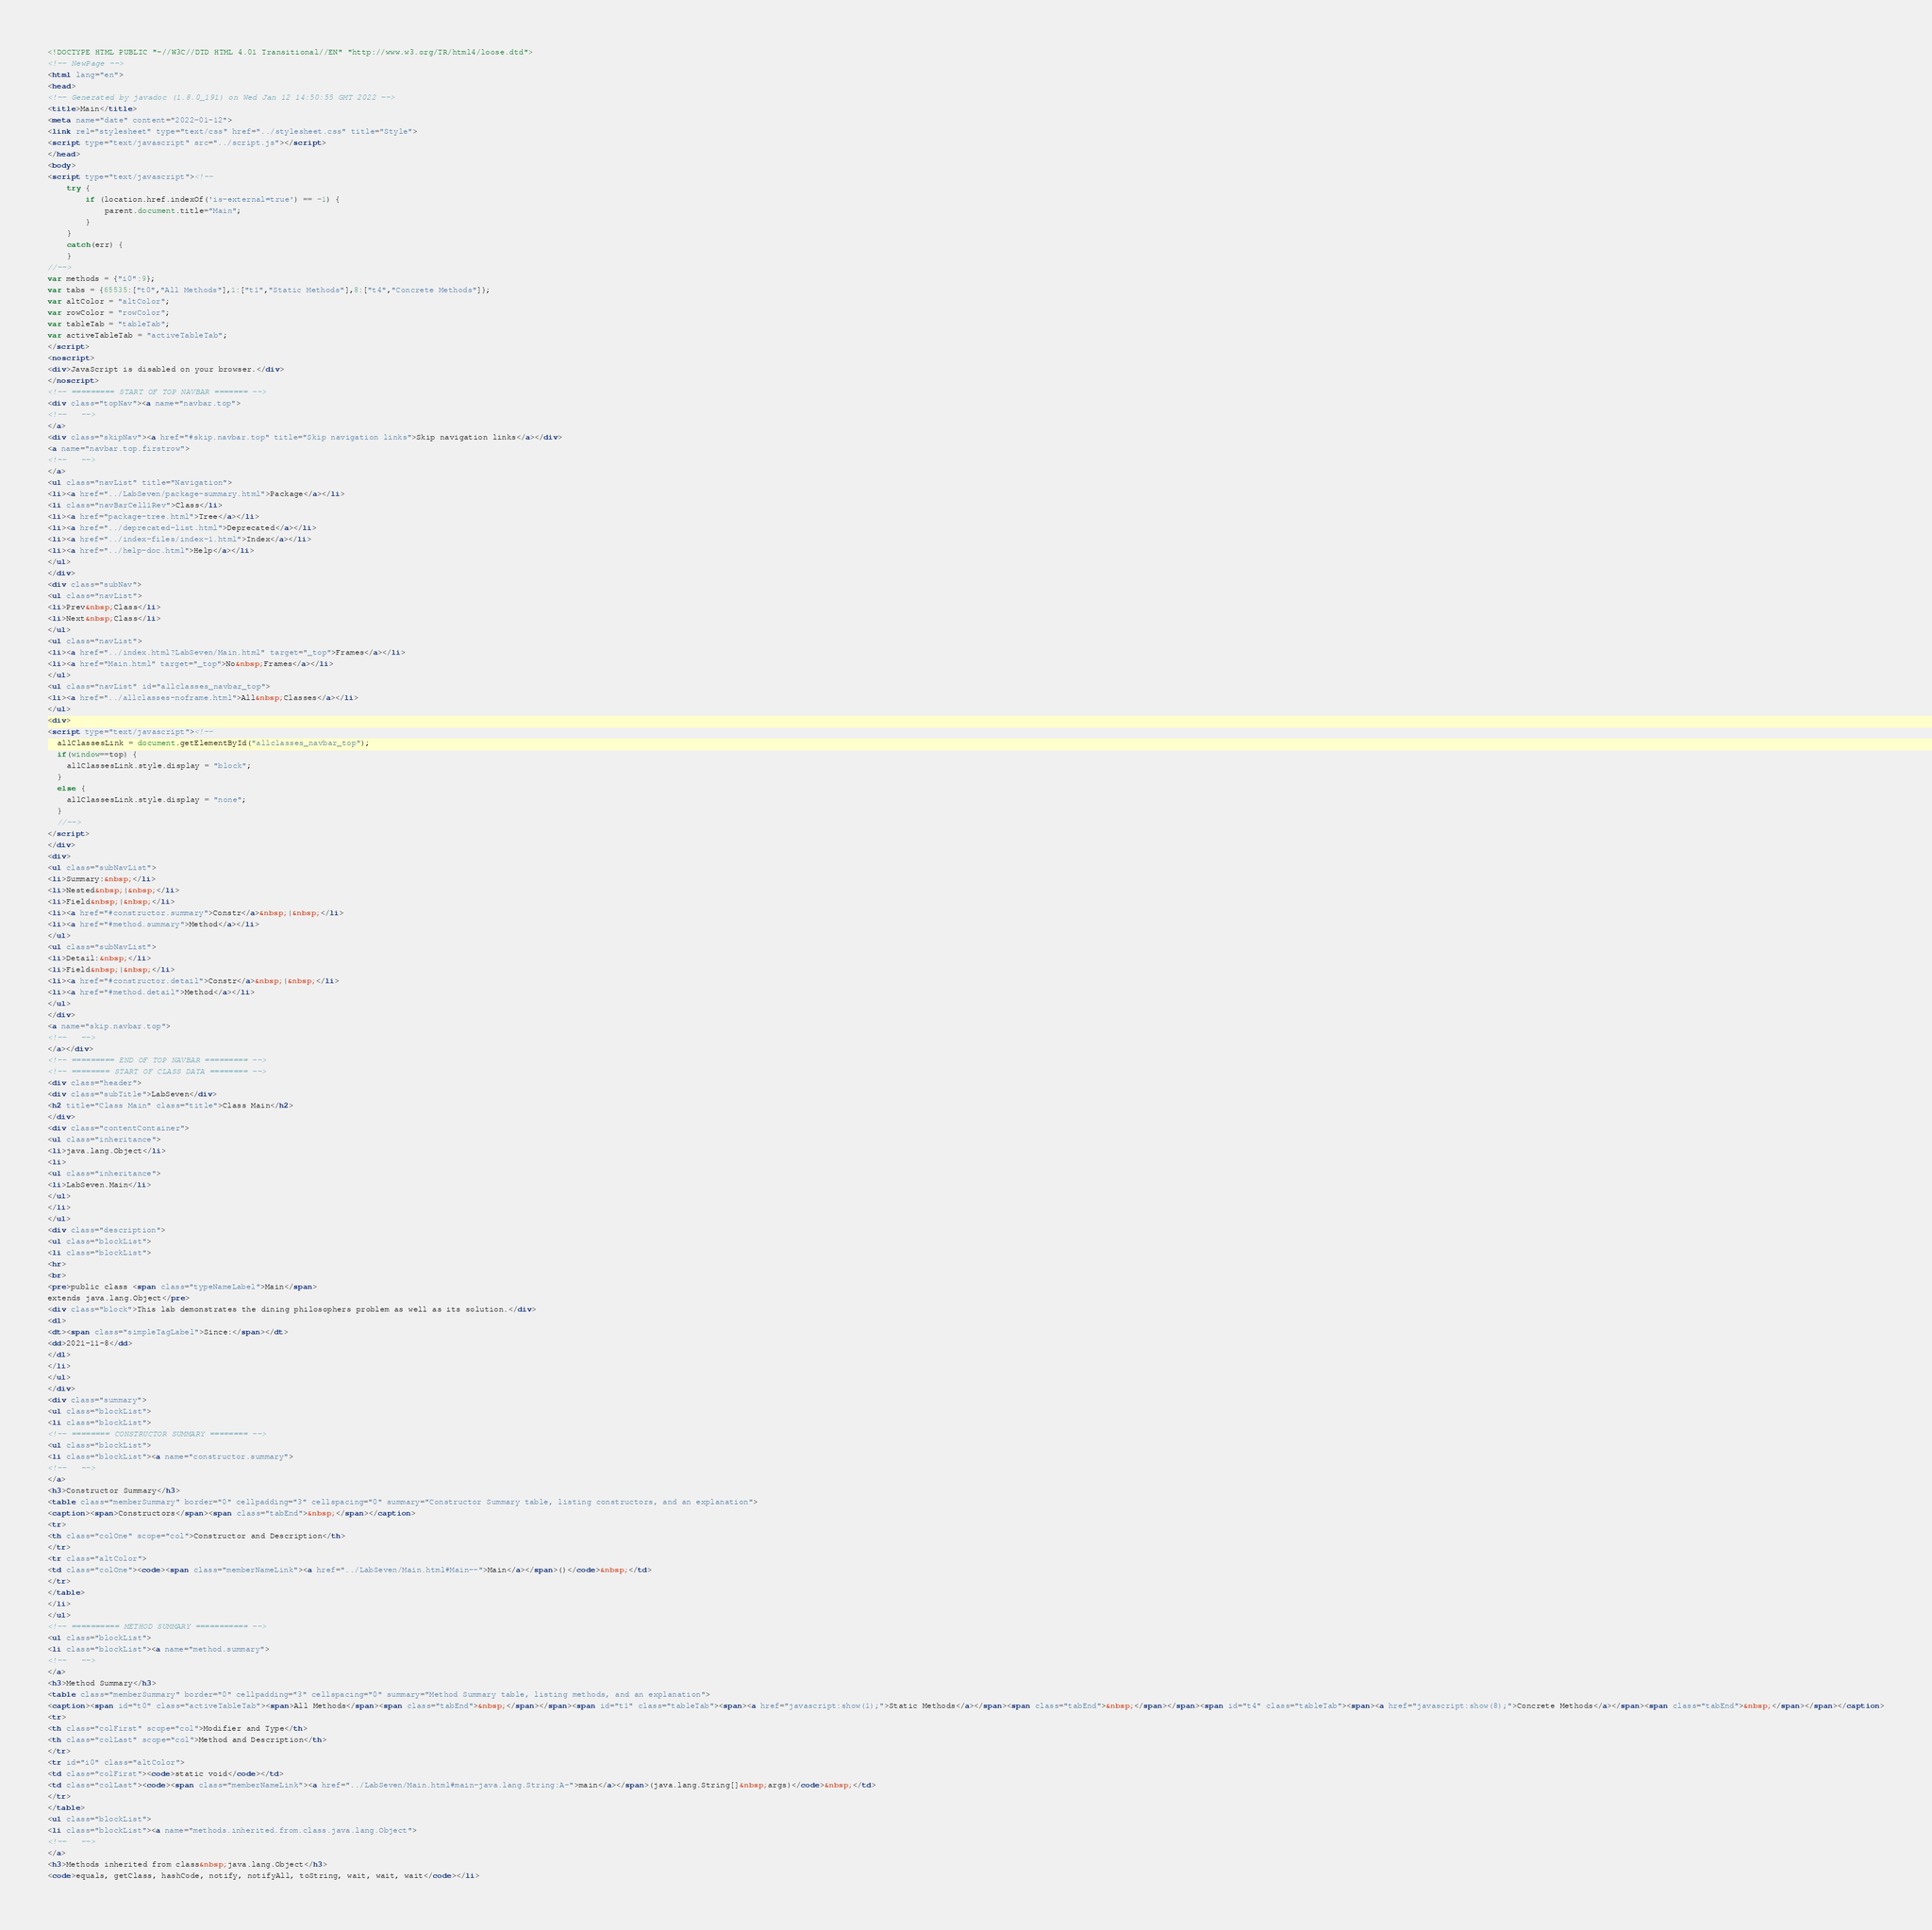Convert code to text. <code><loc_0><loc_0><loc_500><loc_500><_HTML_><!DOCTYPE HTML PUBLIC "-//W3C//DTD HTML 4.01 Transitional//EN" "http://www.w3.org/TR/html4/loose.dtd">
<!-- NewPage -->
<html lang="en">
<head>
<!-- Generated by javadoc (1.8.0_191) on Wed Jan 12 14:50:55 GMT 2022 -->
<title>Main</title>
<meta name="date" content="2022-01-12">
<link rel="stylesheet" type="text/css" href="../stylesheet.css" title="Style">
<script type="text/javascript" src="../script.js"></script>
</head>
<body>
<script type="text/javascript"><!--
    try {
        if (location.href.indexOf('is-external=true') == -1) {
            parent.document.title="Main";
        }
    }
    catch(err) {
    }
//-->
var methods = {"i0":9};
var tabs = {65535:["t0","All Methods"],1:["t1","Static Methods"],8:["t4","Concrete Methods"]};
var altColor = "altColor";
var rowColor = "rowColor";
var tableTab = "tableTab";
var activeTableTab = "activeTableTab";
</script>
<noscript>
<div>JavaScript is disabled on your browser.</div>
</noscript>
<!-- ========= START OF TOP NAVBAR ======= -->
<div class="topNav"><a name="navbar.top">
<!--   -->
</a>
<div class="skipNav"><a href="#skip.navbar.top" title="Skip navigation links">Skip navigation links</a></div>
<a name="navbar.top.firstrow">
<!--   -->
</a>
<ul class="navList" title="Navigation">
<li><a href="../LabSeven/package-summary.html">Package</a></li>
<li class="navBarCell1Rev">Class</li>
<li><a href="package-tree.html">Tree</a></li>
<li><a href="../deprecated-list.html">Deprecated</a></li>
<li><a href="../index-files/index-1.html">Index</a></li>
<li><a href="../help-doc.html">Help</a></li>
</ul>
</div>
<div class="subNav">
<ul class="navList">
<li>Prev&nbsp;Class</li>
<li>Next&nbsp;Class</li>
</ul>
<ul class="navList">
<li><a href="../index.html?LabSeven/Main.html" target="_top">Frames</a></li>
<li><a href="Main.html" target="_top">No&nbsp;Frames</a></li>
</ul>
<ul class="navList" id="allclasses_navbar_top">
<li><a href="../allclasses-noframe.html">All&nbsp;Classes</a></li>
</ul>
<div>
<script type="text/javascript"><!--
  allClassesLink = document.getElementById("allclasses_navbar_top");
  if(window==top) {
    allClassesLink.style.display = "block";
  }
  else {
    allClassesLink.style.display = "none";
  }
  //-->
</script>
</div>
<div>
<ul class="subNavList">
<li>Summary:&nbsp;</li>
<li>Nested&nbsp;|&nbsp;</li>
<li>Field&nbsp;|&nbsp;</li>
<li><a href="#constructor.summary">Constr</a>&nbsp;|&nbsp;</li>
<li><a href="#method.summary">Method</a></li>
</ul>
<ul class="subNavList">
<li>Detail:&nbsp;</li>
<li>Field&nbsp;|&nbsp;</li>
<li><a href="#constructor.detail">Constr</a>&nbsp;|&nbsp;</li>
<li><a href="#method.detail">Method</a></li>
</ul>
</div>
<a name="skip.navbar.top">
<!--   -->
</a></div>
<!-- ========= END OF TOP NAVBAR ========= -->
<!-- ======== START OF CLASS DATA ======== -->
<div class="header">
<div class="subTitle">LabSeven</div>
<h2 title="Class Main" class="title">Class Main</h2>
</div>
<div class="contentContainer">
<ul class="inheritance">
<li>java.lang.Object</li>
<li>
<ul class="inheritance">
<li>LabSeven.Main</li>
</ul>
</li>
</ul>
<div class="description">
<ul class="blockList">
<li class="blockList">
<hr>
<br>
<pre>public class <span class="typeNameLabel">Main</span>
extends java.lang.Object</pre>
<div class="block">This lab demonstrates the dining philosophers problem as well as its solution.</div>
<dl>
<dt><span class="simpleTagLabel">Since:</span></dt>
<dd>2021-11-8</dd>
</dl>
</li>
</ul>
</div>
<div class="summary">
<ul class="blockList">
<li class="blockList">
<!-- ======== CONSTRUCTOR SUMMARY ======== -->
<ul class="blockList">
<li class="blockList"><a name="constructor.summary">
<!--   -->
</a>
<h3>Constructor Summary</h3>
<table class="memberSummary" border="0" cellpadding="3" cellspacing="0" summary="Constructor Summary table, listing constructors, and an explanation">
<caption><span>Constructors</span><span class="tabEnd">&nbsp;</span></caption>
<tr>
<th class="colOne" scope="col">Constructor and Description</th>
</tr>
<tr class="altColor">
<td class="colOne"><code><span class="memberNameLink"><a href="../LabSeven/Main.html#Main--">Main</a></span>()</code>&nbsp;</td>
</tr>
</table>
</li>
</ul>
<!-- ========== METHOD SUMMARY =========== -->
<ul class="blockList">
<li class="blockList"><a name="method.summary">
<!--   -->
</a>
<h3>Method Summary</h3>
<table class="memberSummary" border="0" cellpadding="3" cellspacing="0" summary="Method Summary table, listing methods, and an explanation">
<caption><span id="t0" class="activeTableTab"><span>All Methods</span><span class="tabEnd">&nbsp;</span></span><span id="t1" class="tableTab"><span><a href="javascript:show(1);">Static Methods</a></span><span class="tabEnd">&nbsp;</span></span><span id="t4" class="tableTab"><span><a href="javascript:show(8);">Concrete Methods</a></span><span class="tabEnd">&nbsp;</span></span></caption>
<tr>
<th class="colFirst" scope="col">Modifier and Type</th>
<th class="colLast" scope="col">Method and Description</th>
</tr>
<tr id="i0" class="altColor">
<td class="colFirst"><code>static void</code></td>
<td class="colLast"><code><span class="memberNameLink"><a href="../LabSeven/Main.html#main-java.lang.String:A-">main</a></span>(java.lang.String[]&nbsp;args)</code>&nbsp;</td>
</tr>
</table>
<ul class="blockList">
<li class="blockList"><a name="methods.inherited.from.class.java.lang.Object">
<!--   -->
</a>
<h3>Methods inherited from class&nbsp;java.lang.Object</h3>
<code>equals, getClass, hashCode, notify, notifyAll, toString, wait, wait, wait</code></li></code> 